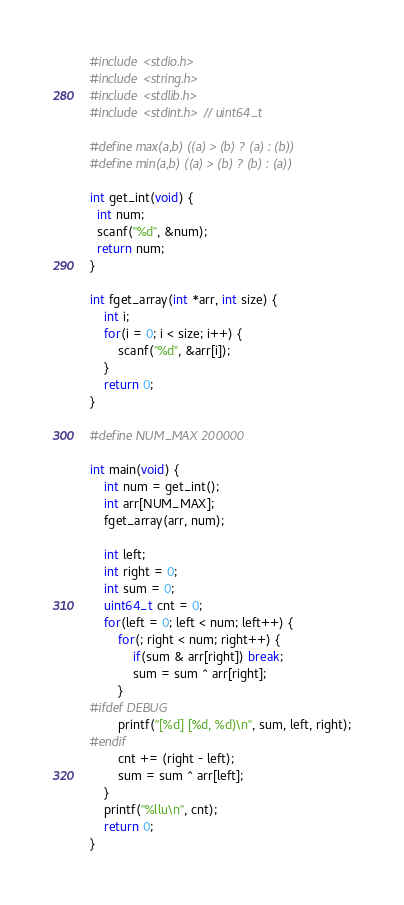Convert code to text. <code><loc_0><loc_0><loc_500><loc_500><_C_>#include <stdio.h>
#include <string.h>
#include <stdlib.h>
#include <stdint.h> // uint64_t

#define max(a,b) ((a) > (b) ? (a) : (b))
#define min(a,b) ((a) > (b) ? (b) : (a))

int get_int(void) {
  int num;
  scanf("%d", &num);
  return num;
}

int fget_array(int *arr, int size) {
    int i;
    for(i = 0; i < size; i++) {
        scanf("%d", &arr[i]);
    }
    return 0;
}

#define NUM_MAX 200000

int main(void) {
    int num = get_int();
    int arr[NUM_MAX];
    fget_array(arr, num);

    int left;
    int right = 0;
    int sum = 0;
    uint64_t cnt = 0;
    for(left = 0; left < num; left++) {
        for(; right < num; right++) {
            if(sum & arr[right]) break;
            sum = sum ^ arr[right];
        }
#ifdef DEBUG
        printf("[%d] [%d, %d)\n", sum, left, right);
#endif
        cnt += (right - left);
        sum = sum ^ arr[left];
    }
    printf("%llu\n", cnt);
    return 0;
}</code> 